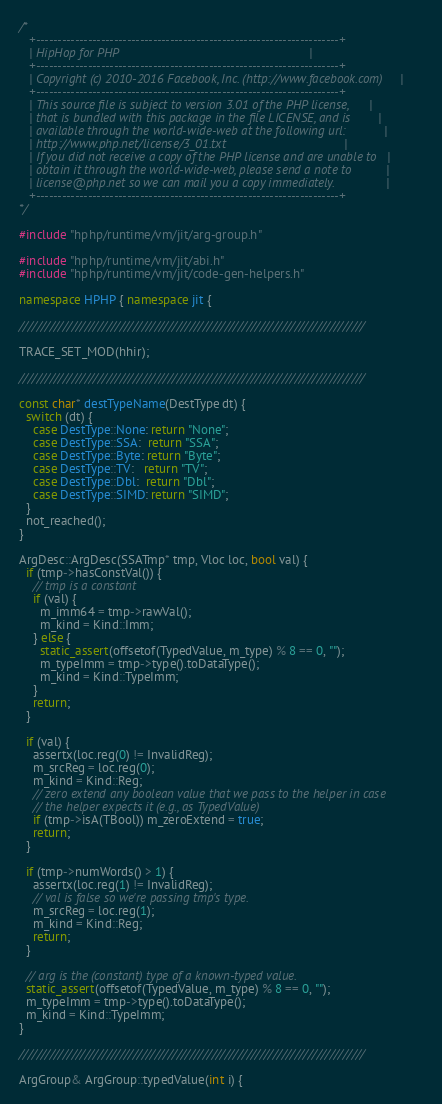<code> <loc_0><loc_0><loc_500><loc_500><_C++_>/*
   +----------------------------------------------------------------------+
   | HipHop for PHP                                                       |
   +----------------------------------------------------------------------+
   | Copyright (c) 2010-2016 Facebook, Inc. (http://www.facebook.com)     |
   +----------------------------------------------------------------------+
   | This source file is subject to version 3.01 of the PHP license,      |
   | that is bundled with this package in the file LICENSE, and is        |
   | available through the world-wide-web at the following url:           |
   | http://www.php.net/license/3_01.txt                                  |
   | If you did not receive a copy of the PHP license and are unable to   |
   | obtain it through the world-wide-web, please send a note to          |
   | license@php.net so we can mail you a copy immediately.               |
   +----------------------------------------------------------------------+
*/

#include "hphp/runtime/vm/jit/arg-group.h"

#include "hphp/runtime/vm/jit/abi.h"
#include "hphp/runtime/vm/jit/code-gen-helpers.h"

namespace HPHP { namespace jit {

///////////////////////////////////////////////////////////////////////////////

TRACE_SET_MOD(hhir);

///////////////////////////////////////////////////////////////////////////////

const char* destTypeName(DestType dt) {
  switch (dt) {
    case DestType::None: return "None";
    case DestType::SSA:  return "SSA";
    case DestType::Byte: return "Byte";
    case DestType::TV:   return "TV";
    case DestType::Dbl:  return "Dbl";
    case DestType::SIMD: return "SIMD";
  }
  not_reached();
}

ArgDesc::ArgDesc(SSATmp* tmp, Vloc loc, bool val) {
  if (tmp->hasConstVal()) {
    // tmp is a constant
    if (val) {
      m_imm64 = tmp->rawVal();
      m_kind = Kind::Imm;
    } else {
      static_assert(offsetof(TypedValue, m_type) % 8 == 0, "");
      m_typeImm = tmp->type().toDataType();
      m_kind = Kind::TypeImm;
    }
    return;
  }

  if (val) {
    assertx(loc.reg(0) != InvalidReg);
    m_srcReg = loc.reg(0);
    m_kind = Kind::Reg;
    // zero extend any boolean value that we pass to the helper in case
    // the helper expects it (e.g., as TypedValue)
    if (tmp->isA(TBool)) m_zeroExtend = true;
    return;
  }

  if (tmp->numWords() > 1) {
    assertx(loc.reg(1) != InvalidReg);
    // val is false so we're passing tmp's type.
    m_srcReg = loc.reg(1);
    m_kind = Kind::Reg;
    return;
  }

  // arg is the (constant) type of a known-typed value.
  static_assert(offsetof(TypedValue, m_type) % 8 == 0, "");
  m_typeImm = tmp->type().toDataType();
  m_kind = Kind::TypeImm;
}

///////////////////////////////////////////////////////////////////////////////

ArgGroup& ArgGroup::typedValue(int i) {</code> 